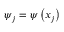<formula> <loc_0><loc_0><loc_500><loc_500>\psi _ { j } = \psi \left ( x _ { j } \right )</formula> 